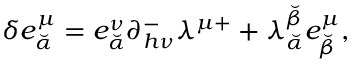<formula> <loc_0><loc_0><loc_500><loc_500>\delta e _ { \breve { \alpha } } ^ { \mu } = e _ { \breve { \alpha } } ^ { \nu } \partial _ { h \nu } ^ { - } \lambda ^ { \mu + } + \lambda _ { \breve { \alpha } } ^ { \breve { \beta } } e _ { \breve { \beta } } ^ { \mu } ,</formula> 